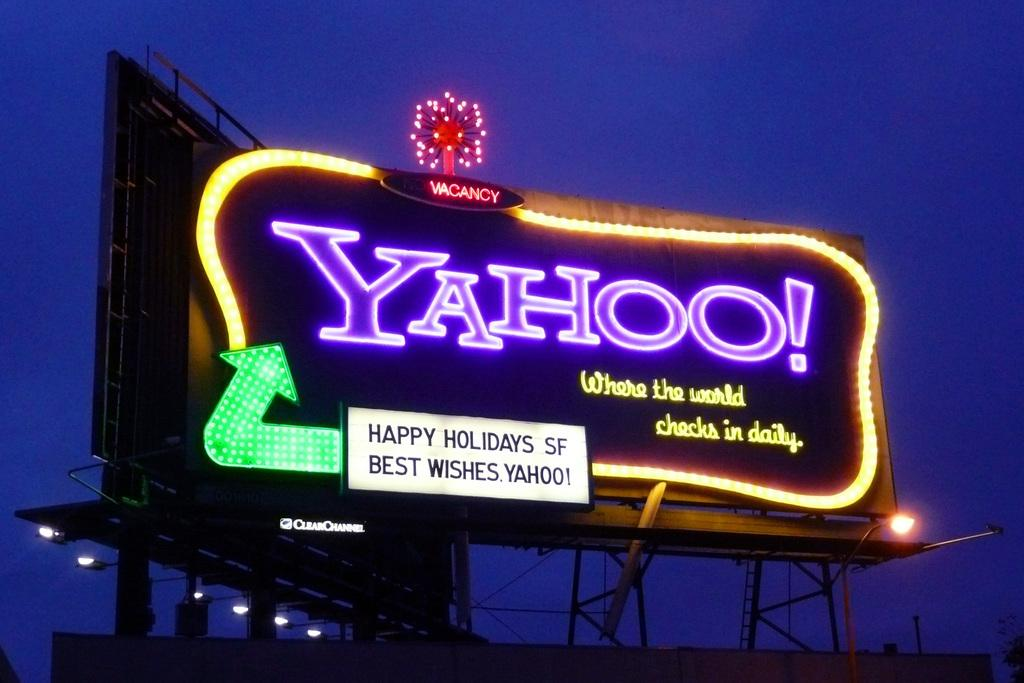Provide a one-sentence caption for the provided image. A billboard of Yahoo to wish the people a happy holidays. 